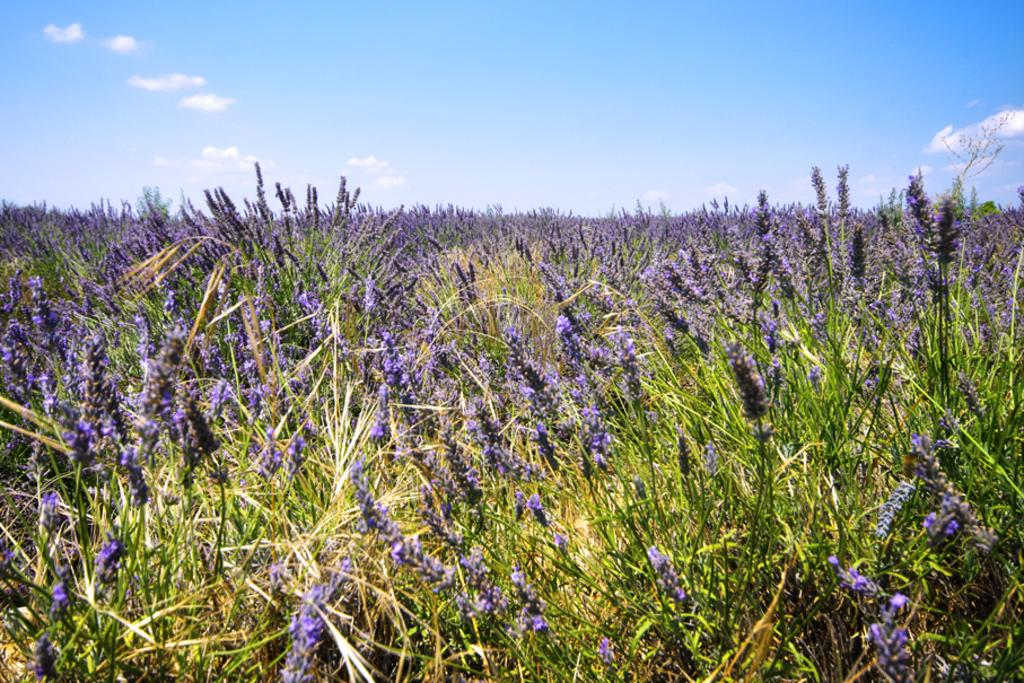What type of flowers can be seen in the image? There are purple color flowers in the image. What is the color of the grass in the image? There is green grass in the image. How would you describe the color of the sky in the image? The sky is a combination of white and blue colors. How many dimes can be seen scattered among the flowers in the image? There are no dimes present in the image; it only features flowers, grass, and the sky. What type of stitch is used to create the pattern on the ornament in the image? There is no ornament present in the image, so it is not possible to determine the type of stitch used. 